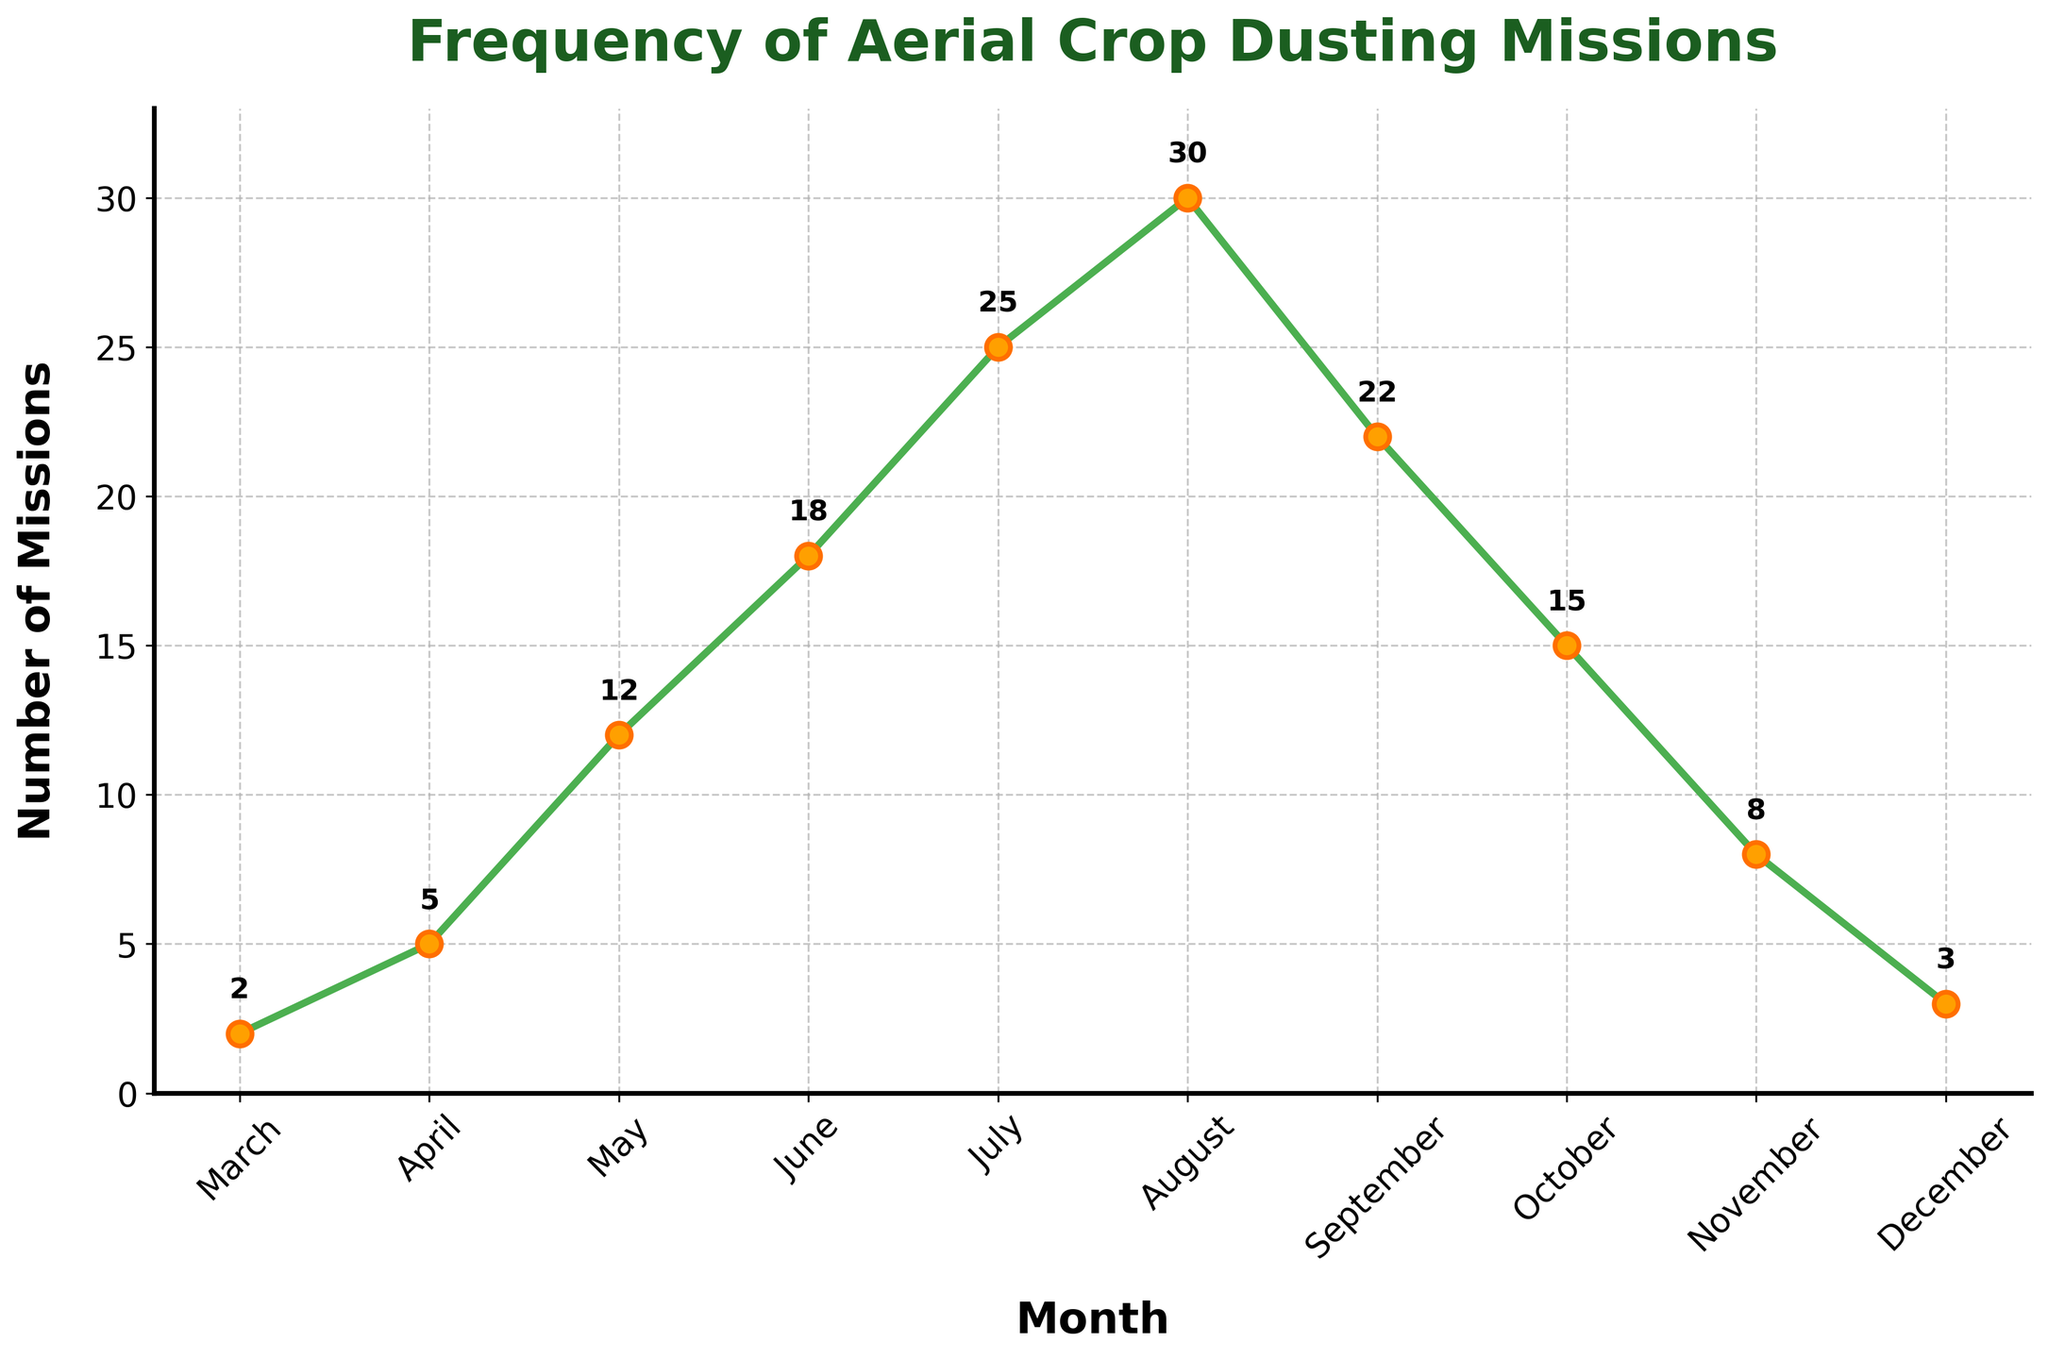Which month has the highest number of crop dusting missions? To find the month with the highest number of missions, look for the peak value on the line chart. In this case, the highest point corresponds to 30 missions in August.
Answer: August How many crop dusting missions were conducted in July compared to May? To compare, find the values for both months and calculate the difference. July has 25 missions and May has 12 missions. The difference is 25 - 12 = 13 missions.
Answer: July had 13 more missions than May What is the total number of crop dusting missions from March to June? Add the number of missions for each month from March to June: 2 (March) + 5 (April) + 12 (May) + 18 (June) = 37 missions.
Answer: 37 missions During which months did the number of crop dusting missions decline? Look for downward trends in the line chart. The number of missions declined in September (22), October (15), November (8), and December (3).
Answer: September, October, November, December What is the difference in the number of crop dusting missions between the peak month and the month with the least missions? Identify the peak (August with 30 missions) and the least (March with 2 missions), then compute the difference: 30 - 2 = 28 missions.
Answer: 28 missions What's the average number of crop dusting missions from March to December? Calculate the total number of missions over the period and divide by the number of months: (2 + 5 + 12 + 18 + 25 + 30 + 22 + 15 + 8 + 3) / 10 = 14 missions per month on average.
Answer: 14 missions What is the visual indication of the number of crop dusting missions for each month? Each month's number of missions is indicated by the height of the marker on the line chart; higher markers represent more missions.
Answer: Higher markers show more missions Which months have more than 20 crop dusting missions? Identify months where the value exceeds 20: July (25), August (30), and September (22).
Answer: July, August, September How does the number of crop dusting missions in April compare to November? Compare the values for both months: April has 5 missions while November has 8 missions. November has 3 more missions than April.
Answer: April has 3 fewer missions than November What pattern can you observe in the number of missions from June to August? The number of crop dusting missions increases consistently from June (18) to August (30), indicating an upward trend.
Answer: Increasing trend 